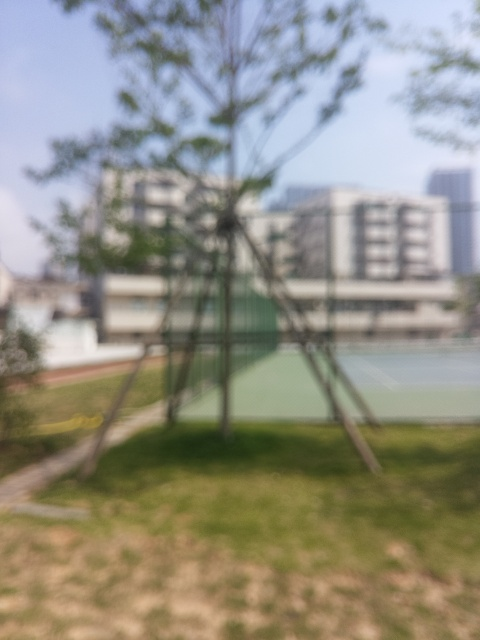Despite the blurriness, what can you say about the maintenance of this area? The image suggests manicured greenery and structured support for a tree, which could indicate regular maintenance of the space. The overall impression is of an orderly and cared-for environment. 